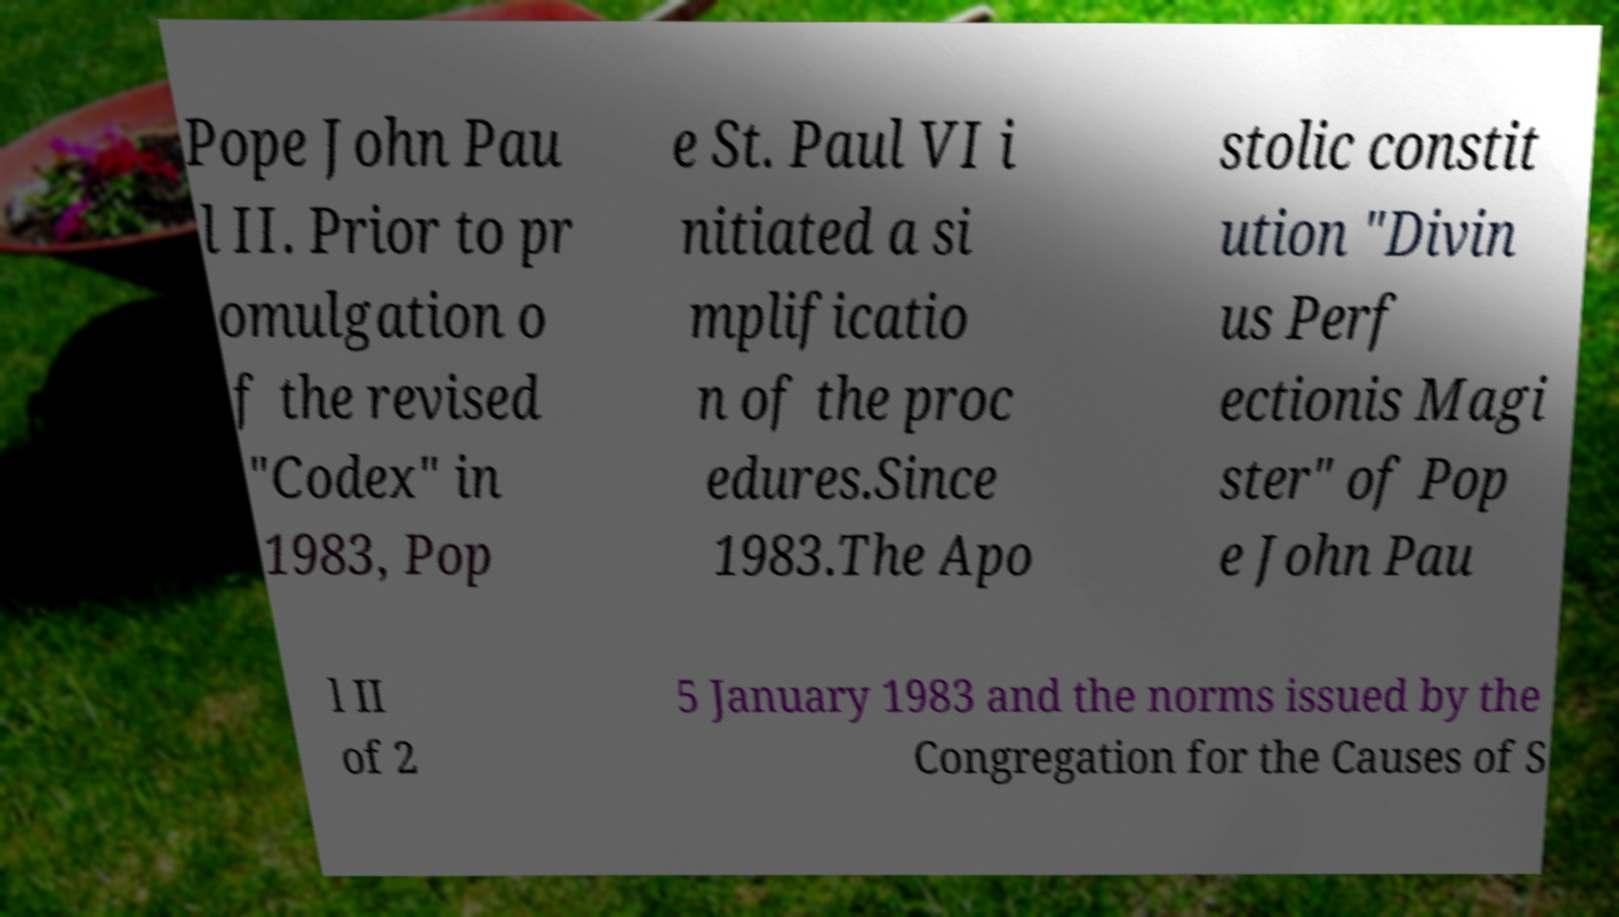Please identify and transcribe the text found in this image. Pope John Pau l II. Prior to pr omulgation o f the revised "Codex" in 1983, Pop e St. Paul VI i nitiated a si mplificatio n of the proc edures.Since 1983.The Apo stolic constit ution "Divin us Perf ectionis Magi ster" of Pop e John Pau l II of 2 5 January 1983 and the norms issued by the Congregation for the Causes of S 